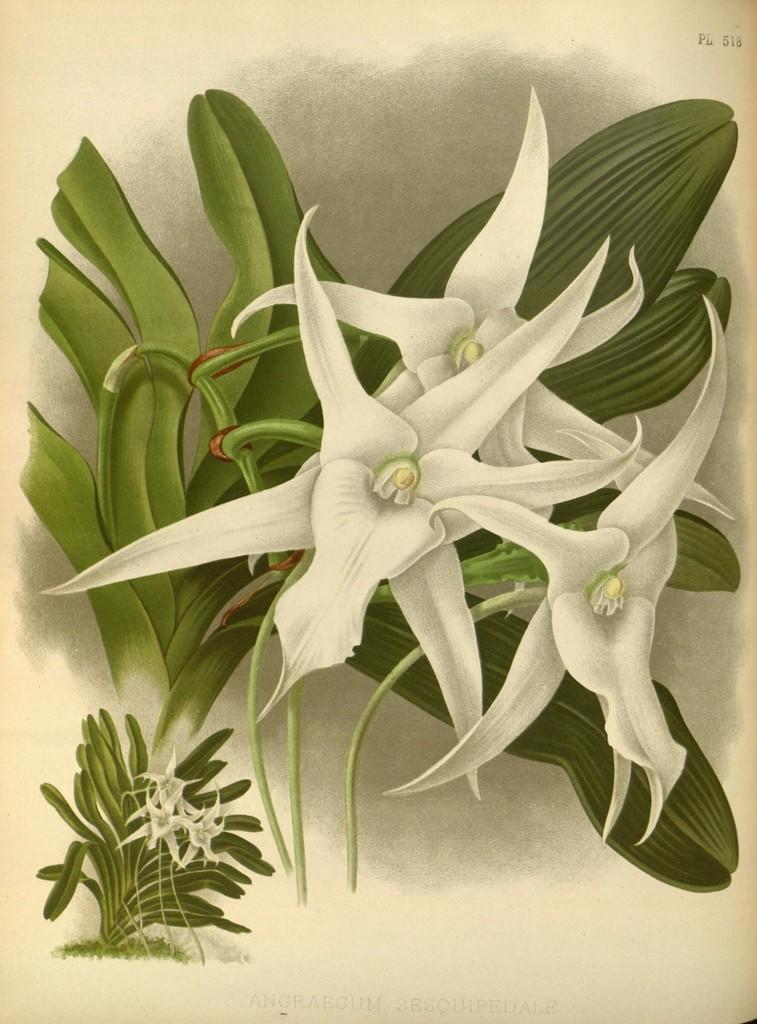Please provide a concise description of this image. In this picture we can see art of flowers and leaves. 